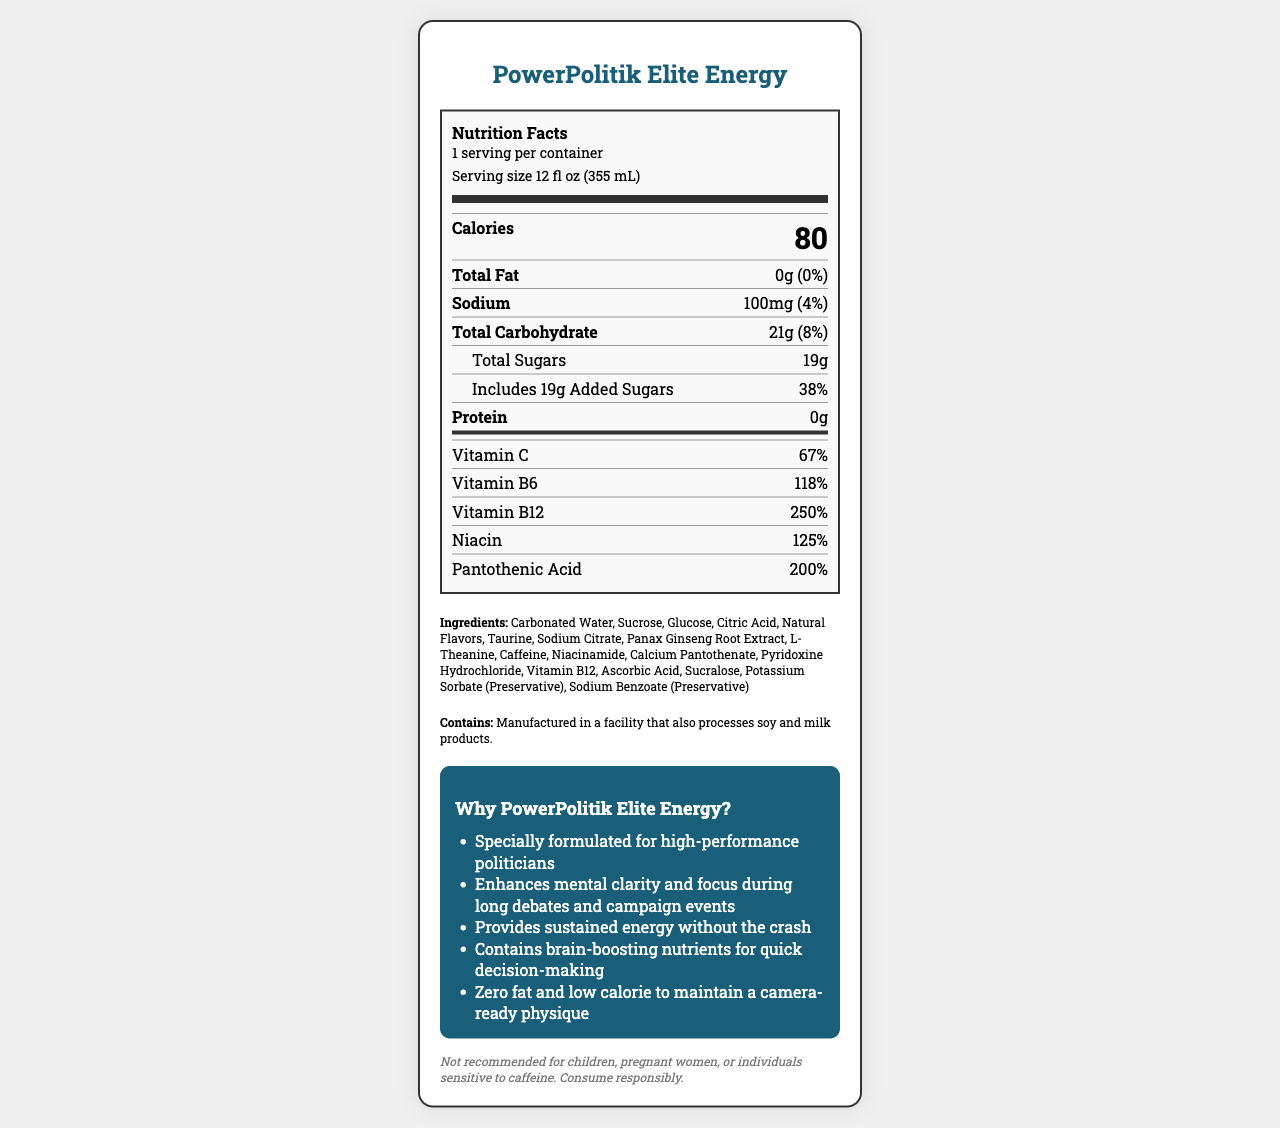what is the serving size? The serving size is mentioned at the top of the Nutrition Facts section as "Serving size 12 fl oz (355 mL)".
Answer: 12 fl oz (355 mL) how many calories are in one serving? The number of calories is displayed prominently in bold next to the "Calories" label.
Answer: 80 what is the daily value percentage of Total Fat? The daily value percentage of Total Fat is shown as "0%" next to the "Total Fat" label.
Answer: 0% how much sodium is in one serving? The amount of sodium per serving is listed as "100mg" in the document.
Answer: 100mg how much added sugars does this product contain? The total added sugars are specifically noted as "Includes 19g Added Sugars".
Answer: 19g what is the amount of Vitamin B6 in one serving? The amount of Vitamin B6 is indicated as "2mg" in the vitamins section.
Answer: 2mg how much caffeine is in one serving? The caffeine content is mentioned at the bottom section of the label as "Caffeine 200mg".
Answer: 200mg what allergens are mentioned on the label? The allergen information is listed toward the bottom of the document stating, "Manufactured in a facility that also processes soy and milk products."
Answer: Manufactured in a facility that also processes soy and milk products which nutrient has the highest daily value percentage? A. Vitamin C B. Vitamin B6 C. Vitamin B12 Vitamin B12 is shown with a daily value of 250%, which is higher than the daily values of the other options.
Answer: C. Vitamin B12 how many grams of total carbohydrate are in one serving? A. 38g B. 19g C. 21g D. 100mg The total carbohydrate is mentioned as "21g" on the nutrient label.
Answer: C. 21g does this product contain any fat? The total fat is listed as "0g" indicating no fat content.
Answer: No is this product suitable for children? The disclaimer explicitly states, "Not recommended for children,".
Answer: No summarize the main idea of this document. The document outlines the nutrition facts and ingredients of PowerPolitik Elite Energy, targeting busy politicians. It highlights the drink's low-calorie content, lack of fat, significant vitamin content, and high caffeine. The marketing claims emphasize its benefits for mental clarity, focus, and sustained energy, while the disclaimer advises against use by children and sensitive individuals.
Answer: The document provides the nutritional facts for PowerPolitik Elite Energy, a premium energy drink formulated for high-performance politicians. It details serving size, calories, macronutrients, vitamins, ingredients, and allergen information. Additionally, the document includes marketing claims about the beverage's benefits and a disclaimer about its consumption. how does the product claim to benefit its primary consumers? The marketing section lists benefits such as enhancing mental clarity and focus, providing sustained energy, and containing brain-boosting nutrients for quick decision-making.
Answer: Enhances mental clarity, focus, sustained energy, quick decision-making what is the primary sweetener in this product? The label lists both sucrose and glucose under ingredients, but it does not specify which one is the primary sweetener.
Answer: Cannot be determined what are the brain-boosting nutrients mentioned? The marketing section highlights the brain-boosting nutrients present in the drink, which include several vitamins and L-Theanine.
Answer: Vitamin B6, Vitamin B12, Niacin, Pantothenic Acid, L-Theanine 